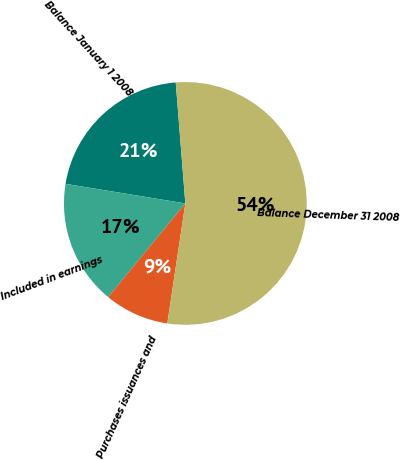<chart> <loc_0><loc_0><loc_500><loc_500><pie_chart><fcel>Balance January 1 2008<fcel>Included in earnings<fcel>Purchases issuances and<fcel>Balance December 31 2008<nl><fcel>21.16%<fcel>16.61%<fcel>8.6%<fcel>53.64%<nl></chart> 